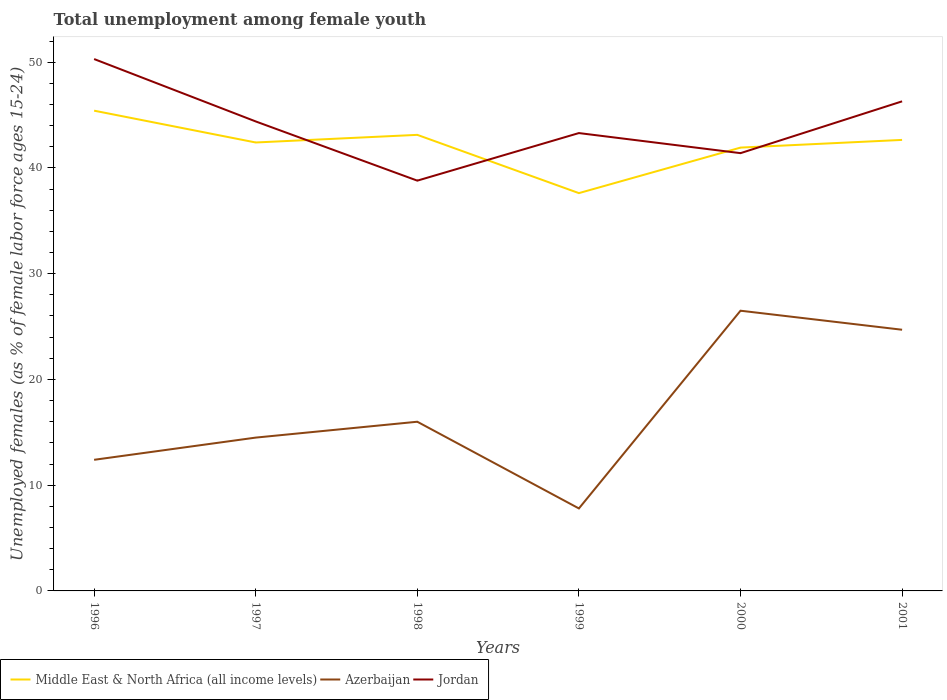Does the line corresponding to Azerbaijan intersect with the line corresponding to Middle East & North Africa (all income levels)?
Your answer should be very brief. No. Across all years, what is the maximum percentage of unemployed females in in Azerbaijan?
Your answer should be very brief. 7.8. What is the difference between the highest and the second highest percentage of unemployed females in in Azerbaijan?
Your answer should be very brief. 18.7. Does the graph contain any zero values?
Your answer should be compact. No. Does the graph contain grids?
Your answer should be very brief. No. Where does the legend appear in the graph?
Offer a very short reply. Bottom left. How are the legend labels stacked?
Give a very brief answer. Horizontal. What is the title of the graph?
Keep it short and to the point. Total unemployment among female youth. Does "Comoros" appear as one of the legend labels in the graph?
Make the answer very short. No. What is the label or title of the Y-axis?
Your answer should be very brief. Unemployed females (as % of female labor force ages 15-24). What is the Unemployed females (as % of female labor force ages 15-24) of Middle East & North Africa (all income levels) in 1996?
Keep it short and to the point. 45.42. What is the Unemployed females (as % of female labor force ages 15-24) in Azerbaijan in 1996?
Offer a very short reply. 12.4. What is the Unemployed females (as % of female labor force ages 15-24) in Jordan in 1996?
Offer a terse response. 50.3. What is the Unemployed females (as % of female labor force ages 15-24) in Middle East & North Africa (all income levels) in 1997?
Your answer should be compact. 42.41. What is the Unemployed females (as % of female labor force ages 15-24) in Azerbaijan in 1997?
Provide a succinct answer. 14.5. What is the Unemployed females (as % of female labor force ages 15-24) in Jordan in 1997?
Your response must be concise. 44.4. What is the Unemployed females (as % of female labor force ages 15-24) in Middle East & North Africa (all income levels) in 1998?
Your answer should be very brief. 43.13. What is the Unemployed females (as % of female labor force ages 15-24) in Jordan in 1998?
Your response must be concise. 38.8. What is the Unemployed females (as % of female labor force ages 15-24) in Middle East & North Africa (all income levels) in 1999?
Provide a short and direct response. 37.62. What is the Unemployed females (as % of female labor force ages 15-24) of Azerbaijan in 1999?
Provide a short and direct response. 7.8. What is the Unemployed females (as % of female labor force ages 15-24) of Jordan in 1999?
Make the answer very short. 43.3. What is the Unemployed females (as % of female labor force ages 15-24) of Middle East & North Africa (all income levels) in 2000?
Provide a short and direct response. 41.93. What is the Unemployed females (as % of female labor force ages 15-24) in Azerbaijan in 2000?
Your answer should be very brief. 26.5. What is the Unemployed females (as % of female labor force ages 15-24) of Jordan in 2000?
Your answer should be compact. 41.4. What is the Unemployed females (as % of female labor force ages 15-24) of Middle East & North Africa (all income levels) in 2001?
Offer a very short reply. 42.65. What is the Unemployed females (as % of female labor force ages 15-24) of Azerbaijan in 2001?
Your response must be concise. 24.7. What is the Unemployed females (as % of female labor force ages 15-24) of Jordan in 2001?
Make the answer very short. 46.3. Across all years, what is the maximum Unemployed females (as % of female labor force ages 15-24) of Middle East & North Africa (all income levels)?
Your answer should be compact. 45.42. Across all years, what is the maximum Unemployed females (as % of female labor force ages 15-24) of Jordan?
Provide a short and direct response. 50.3. Across all years, what is the minimum Unemployed females (as % of female labor force ages 15-24) of Middle East & North Africa (all income levels)?
Your answer should be very brief. 37.62. Across all years, what is the minimum Unemployed females (as % of female labor force ages 15-24) in Azerbaijan?
Make the answer very short. 7.8. Across all years, what is the minimum Unemployed females (as % of female labor force ages 15-24) in Jordan?
Your answer should be compact. 38.8. What is the total Unemployed females (as % of female labor force ages 15-24) of Middle East & North Africa (all income levels) in the graph?
Ensure brevity in your answer.  253.15. What is the total Unemployed females (as % of female labor force ages 15-24) in Azerbaijan in the graph?
Your response must be concise. 101.9. What is the total Unemployed females (as % of female labor force ages 15-24) of Jordan in the graph?
Your response must be concise. 264.5. What is the difference between the Unemployed females (as % of female labor force ages 15-24) in Middle East & North Africa (all income levels) in 1996 and that in 1997?
Your answer should be very brief. 3.01. What is the difference between the Unemployed females (as % of female labor force ages 15-24) of Jordan in 1996 and that in 1997?
Provide a succinct answer. 5.9. What is the difference between the Unemployed females (as % of female labor force ages 15-24) of Middle East & North Africa (all income levels) in 1996 and that in 1998?
Keep it short and to the point. 2.29. What is the difference between the Unemployed females (as % of female labor force ages 15-24) of Jordan in 1996 and that in 1998?
Offer a terse response. 11.5. What is the difference between the Unemployed females (as % of female labor force ages 15-24) of Middle East & North Africa (all income levels) in 1996 and that in 1999?
Ensure brevity in your answer.  7.8. What is the difference between the Unemployed females (as % of female labor force ages 15-24) in Azerbaijan in 1996 and that in 1999?
Keep it short and to the point. 4.6. What is the difference between the Unemployed females (as % of female labor force ages 15-24) of Middle East & North Africa (all income levels) in 1996 and that in 2000?
Provide a short and direct response. 3.49. What is the difference between the Unemployed females (as % of female labor force ages 15-24) in Azerbaijan in 1996 and that in 2000?
Your response must be concise. -14.1. What is the difference between the Unemployed females (as % of female labor force ages 15-24) of Jordan in 1996 and that in 2000?
Ensure brevity in your answer.  8.9. What is the difference between the Unemployed females (as % of female labor force ages 15-24) of Middle East & North Africa (all income levels) in 1996 and that in 2001?
Provide a succinct answer. 2.76. What is the difference between the Unemployed females (as % of female labor force ages 15-24) in Middle East & North Africa (all income levels) in 1997 and that in 1998?
Make the answer very short. -0.72. What is the difference between the Unemployed females (as % of female labor force ages 15-24) of Middle East & North Africa (all income levels) in 1997 and that in 1999?
Give a very brief answer. 4.79. What is the difference between the Unemployed females (as % of female labor force ages 15-24) of Azerbaijan in 1997 and that in 1999?
Offer a terse response. 6.7. What is the difference between the Unemployed females (as % of female labor force ages 15-24) of Jordan in 1997 and that in 1999?
Your response must be concise. 1.1. What is the difference between the Unemployed females (as % of female labor force ages 15-24) in Middle East & North Africa (all income levels) in 1997 and that in 2000?
Your answer should be very brief. 0.48. What is the difference between the Unemployed females (as % of female labor force ages 15-24) in Azerbaijan in 1997 and that in 2000?
Keep it short and to the point. -12. What is the difference between the Unemployed females (as % of female labor force ages 15-24) of Middle East & North Africa (all income levels) in 1997 and that in 2001?
Your answer should be compact. -0.24. What is the difference between the Unemployed females (as % of female labor force ages 15-24) in Jordan in 1997 and that in 2001?
Offer a very short reply. -1.9. What is the difference between the Unemployed females (as % of female labor force ages 15-24) of Middle East & North Africa (all income levels) in 1998 and that in 1999?
Give a very brief answer. 5.51. What is the difference between the Unemployed females (as % of female labor force ages 15-24) in Azerbaijan in 1998 and that in 1999?
Your answer should be very brief. 8.2. What is the difference between the Unemployed females (as % of female labor force ages 15-24) in Middle East & North Africa (all income levels) in 1998 and that in 2000?
Offer a very short reply. 1.2. What is the difference between the Unemployed females (as % of female labor force ages 15-24) of Jordan in 1998 and that in 2000?
Your answer should be very brief. -2.6. What is the difference between the Unemployed females (as % of female labor force ages 15-24) of Middle East & North Africa (all income levels) in 1998 and that in 2001?
Provide a short and direct response. 0.48. What is the difference between the Unemployed females (as % of female labor force ages 15-24) in Jordan in 1998 and that in 2001?
Your answer should be compact. -7.5. What is the difference between the Unemployed females (as % of female labor force ages 15-24) in Middle East & North Africa (all income levels) in 1999 and that in 2000?
Your answer should be very brief. -4.3. What is the difference between the Unemployed females (as % of female labor force ages 15-24) of Azerbaijan in 1999 and that in 2000?
Ensure brevity in your answer.  -18.7. What is the difference between the Unemployed females (as % of female labor force ages 15-24) of Middle East & North Africa (all income levels) in 1999 and that in 2001?
Your answer should be compact. -5.03. What is the difference between the Unemployed females (as % of female labor force ages 15-24) of Azerbaijan in 1999 and that in 2001?
Provide a succinct answer. -16.9. What is the difference between the Unemployed females (as % of female labor force ages 15-24) of Jordan in 1999 and that in 2001?
Your answer should be compact. -3. What is the difference between the Unemployed females (as % of female labor force ages 15-24) of Middle East & North Africa (all income levels) in 2000 and that in 2001?
Provide a succinct answer. -0.73. What is the difference between the Unemployed females (as % of female labor force ages 15-24) in Azerbaijan in 2000 and that in 2001?
Offer a terse response. 1.8. What is the difference between the Unemployed females (as % of female labor force ages 15-24) in Middle East & North Africa (all income levels) in 1996 and the Unemployed females (as % of female labor force ages 15-24) in Azerbaijan in 1997?
Offer a very short reply. 30.92. What is the difference between the Unemployed females (as % of female labor force ages 15-24) in Middle East & North Africa (all income levels) in 1996 and the Unemployed females (as % of female labor force ages 15-24) in Jordan in 1997?
Keep it short and to the point. 1.02. What is the difference between the Unemployed females (as % of female labor force ages 15-24) of Azerbaijan in 1996 and the Unemployed females (as % of female labor force ages 15-24) of Jordan in 1997?
Offer a terse response. -32. What is the difference between the Unemployed females (as % of female labor force ages 15-24) of Middle East & North Africa (all income levels) in 1996 and the Unemployed females (as % of female labor force ages 15-24) of Azerbaijan in 1998?
Offer a very short reply. 29.42. What is the difference between the Unemployed females (as % of female labor force ages 15-24) in Middle East & North Africa (all income levels) in 1996 and the Unemployed females (as % of female labor force ages 15-24) in Jordan in 1998?
Ensure brevity in your answer.  6.62. What is the difference between the Unemployed females (as % of female labor force ages 15-24) of Azerbaijan in 1996 and the Unemployed females (as % of female labor force ages 15-24) of Jordan in 1998?
Your response must be concise. -26.4. What is the difference between the Unemployed females (as % of female labor force ages 15-24) of Middle East & North Africa (all income levels) in 1996 and the Unemployed females (as % of female labor force ages 15-24) of Azerbaijan in 1999?
Offer a very short reply. 37.62. What is the difference between the Unemployed females (as % of female labor force ages 15-24) of Middle East & North Africa (all income levels) in 1996 and the Unemployed females (as % of female labor force ages 15-24) of Jordan in 1999?
Offer a terse response. 2.12. What is the difference between the Unemployed females (as % of female labor force ages 15-24) of Azerbaijan in 1996 and the Unemployed females (as % of female labor force ages 15-24) of Jordan in 1999?
Provide a succinct answer. -30.9. What is the difference between the Unemployed females (as % of female labor force ages 15-24) in Middle East & North Africa (all income levels) in 1996 and the Unemployed females (as % of female labor force ages 15-24) in Azerbaijan in 2000?
Your response must be concise. 18.92. What is the difference between the Unemployed females (as % of female labor force ages 15-24) of Middle East & North Africa (all income levels) in 1996 and the Unemployed females (as % of female labor force ages 15-24) of Jordan in 2000?
Offer a very short reply. 4.02. What is the difference between the Unemployed females (as % of female labor force ages 15-24) of Middle East & North Africa (all income levels) in 1996 and the Unemployed females (as % of female labor force ages 15-24) of Azerbaijan in 2001?
Provide a succinct answer. 20.72. What is the difference between the Unemployed females (as % of female labor force ages 15-24) of Middle East & North Africa (all income levels) in 1996 and the Unemployed females (as % of female labor force ages 15-24) of Jordan in 2001?
Offer a very short reply. -0.88. What is the difference between the Unemployed females (as % of female labor force ages 15-24) in Azerbaijan in 1996 and the Unemployed females (as % of female labor force ages 15-24) in Jordan in 2001?
Provide a short and direct response. -33.9. What is the difference between the Unemployed females (as % of female labor force ages 15-24) of Middle East & North Africa (all income levels) in 1997 and the Unemployed females (as % of female labor force ages 15-24) of Azerbaijan in 1998?
Provide a short and direct response. 26.41. What is the difference between the Unemployed females (as % of female labor force ages 15-24) of Middle East & North Africa (all income levels) in 1997 and the Unemployed females (as % of female labor force ages 15-24) of Jordan in 1998?
Make the answer very short. 3.61. What is the difference between the Unemployed females (as % of female labor force ages 15-24) in Azerbaijan in 1997 and the Unemployed females (as % of female labor force ages 15-24) in Jordan in 1998?
Provide a succinct answer. -24.3. What is the difference between the Unemployed females (as % of female labor force ages 15-24) of Middle East & North Africa (all income levels) in 1997 and the Unemployed females (as % of female labor force ages 15-24) of Azerbaijan in 1999?
Your answer should be compact. 34.61. What is the difference between the Unemployed females (as % of female labor force ages 15-24) of Middle East & North Africa (all income levels) in 1997 and the Unemployed females (as % of female labor force ages 15-24) of Jordan in 1999?
Offer a very short reply. -0.89. What is the difference between the Unemployed females (as % of female labor force ages 15-24) in Azerbaijan in 1997 and the Unemployed females (as % of female labor force ages 15-24) in Jordan in 1999?
Provide a short and direct response. -28.8. What is the difference between the Unemployed females (as % of female labor force ages 15-24) in Middle East & North Africa (all income levels) in 1997 and the Unemployed females (as % of female labor force ages 15-24) in Azerbaijan in 2000?
Your answer should be very brief. 15.91. What is the difference between the Unemployed females (as % of female labor force ages 15-24) in Middle East & North Africa (all income levels) in 1997 and the Unemployed females (as % of female labor force ages 15-24) in Jordan in 2000?
Your answer should be compact. 1.01. What is the difference between the Unemployed females (as % of female labor force ages 15-24) in Azerbaijan in 1997 and the Unemployed females (as % of female labor force ages 15-24) in Jordan in 2000?
Offer a very short reply. -26.9. What is the difference between the Unemployed females (as % of female labor force ages 15-24) of Middle East & North Africa (all income levels) in 1997 and the Unemployed females (as % of female labor force ages 15-24) of Azerbaijan in 2001?
Your answer should be very brief. 17.71. What is the difference between the Unemployed females (as % of female labor force ages 15-24) of Middle East & North Africa (all income levels) in 1997 and the Unemployed females (as % of female labor force ages 15-24) of Jordan in 2001?
Offer a terse response. -3.89. What is the difference between the Unemployed females (as % of female labor force ages 15-24) of Azerbaijan in 1997 and the Unemployed females (as % of female labor force ages 15-24) of Jordan in 2001?
Offer a terse response. -31.8. What is the difference between the Unemployed females (as % of female labor force ages 15-24) of Middle East & North Africa (all income levels) in 1998 and the Unemployed females (as % of female labor force ages 15-24) of Azerbaijan in 1999?
Provide a short and direct response. 35.33. What is the difference between the Unemployed females (as % of female labor force ages 15-24) in Middle East & North Africa (all income levels) in 1998 and the Unemployed females (as % of female labor force ages 15-24) in Jordan in 1999?
Your answer should be compact. -0.17. What is the difference between the Unemployed females (as % of female labor force ages 15-24) of Azerbaijan in 1998 and the Unemployed females (as % of female labor force ages 15-24) of Jordan in 1999?
Give a very brief answer. -27.3. What is the difference between the Unemployed females (as % of female labor force ages 15-24) in Middle East & North Africa (all income levels) in 1998 and the Unemployed females (as % of female labor force ages 15-24) in Azerbaijan in 2000?
Your answer should be compact. 16.63. What is the difference between the Unemployed females (as % of female labor force ages 15-24) in Middle East & North Africa (all income levels) in 1998 and the Unemployed females (as % of female labor force ages 15-24) in Jordan in 2000?
Your answer should be very brief. 1.73. What is the difference between the Unemployed females (as % of female labor force ages 15-24) of Azerbaijan in 1998 and the Unemployed females (as % of female labor force ages 15-24) of Jordan in 2000?
Keep it short and to the point. -25.4. What is the difference between the Unemployed females (as % of female labor force ages 15-24) of Middle East & North Africa (all income levels) in 1998 and the Unemployed females (as % of female labor force ages 15-24) of Azerbaijan in 2001?
Give a very brief answer. 18.43. What is the difference between the Unemployed females (as % of female labor force ages 15-24) of Middle East & North Africa (all income levels) in 1998 and the Unemployed females (as % of female labor force ages 15-24) of Jordan in 2001?
Offer a terse response. -3.17. What is the difference between the Unemployed females (as % of female labor force ages 15-24) of Azerbaijan in 1998 and the Unemployed females (as % of female labor force ages 15-24) of Jordan in 2001?
Your answer should be compact. -30.3. What is the difference between the Unemployed females (as % of female labor force ages 15-24) in Middle East & North Africa (all income levels) in 1999 and the Unemployed females (as % of female labor force ages 15-24) in Azerbaijan in 2000?
Your answer should be compact. 11.12. What is the difference between the Unemployed females (as % of female labor force ages 15-24) in Middle East & North Africa (all income levels) in 1999 and the Unemployed females (as % of female labor force ages 15-24) in Jordan in 2000?
Your response must be concise. -3.78. What is the difference between the Unemployed females (as % of female labor force ages 15-24) of Azerbaijan in 1999 and the Unemployed females (as % of female labor force ages 15-24) of Jordan in 2000?
Offer a terse response. -33.6. What is the difference between the Unemployed females (as % of female labor force ages 15-24) in Middle East & North Africa (all income levels) in 1999 and the Unemployed females (as % of female labor force ages 15-24) in Azerbaijan in 2001?
Make the answer very short. 12.92. What is the difference between the Unemployed females (as % of female labor force ages 15-24) in Middle East & North Africa (all income levels) in 1999 and the Unemployed females (as % of female labor force ages 15-24) in Jordan in 2001?
Ensure brevity in your answer.  -8.68. What is the difference between the Unemployed females (as % of female labor force ages 15-24) in Azerbaijan in 1999 and the Unemployed females (as % of female labor force ages 15-24) in Jordan in 2001?
Provide a short and direct response. -38.5. What is the difference between the Unemployed females (as % of female labor force ages 15-24) of Middle East & North Africa (all income levels) in 2000 and the Unemployed females (as % of female labor force ages 15-24) of Azerbaijan in 2001?
Ensure brevity in your answer.  17.23. What is the difference between the Unemployed females (as % of female labor force ages 15-24) of Middle East & North Africa (all income levels) in 2000 and the Unemployed females (as % of female labor force ages 15-24) of Jordan in 2001?
Ensure brevity in your answer.  -4.37. What is the difference between the Unemployed females (as % of female labor force ages 15-24) of Azerbaijan in 2000 and the Unemployed females (as % of female labor force ages 15-24) of Jordan in 2001?
Your answer should be very brief. -19.8. What is the average Unemployed females (as % of female labor force ages 15-24) in Middle East & North Africa (all income levels) per year?
Make the answer very short. 42.19. What is the average Unemployed females (as % of female labor force ages 15-24) in Azerbaijan per year?
Provide a short and direct response. 16.98. What is the average Unemployed females (as % of female labor force ages 15-24) of Jordan per year?
Your answer should be very brief. 44.08. In the year 1996, what is the difference between the Unemployed females (as % of female labor force ages 15-24) of Middle East & North Africa (all income levels) and Unemployed females (as % of female labor force ages 15-24) of Azerbaijan?
Provide a succinct answer. 33.02. In the year 1996, what is the difference between the Unemployed females (as % of female labor force ages 15-24) in Middle East & North Africa (all income levels) and Unemployed females (as % of female labor force ages 15-24) in Jordan?
Ensure brevity in your answer.  -4.88. In the year 1996, what is the difference between the Unemployed females (as % of female labor force ages 15-24) in Azerbaijan and Unemployed females (as % of female labor force ages 15-24) in Jordan?
Offer a very short reply. -37.9. In the year 1997, what is the difference between the Unemployed females (as % of female labor force ages 15-24) in Middle East & North Africa (all income levels) and Unemployed females (as % of female labor force ages 15-24) in Azerbaijan?
Provide a succinct answer. 27.91. In the year 1997, what is the difference between the Unemployed females (as % of female labor force ages 15-24) of Middle East & North Africa (all income levels) and Unemployed females (as % of female labor force ages 15-24) of Jordan?
Give a very brief answer. -1.99. In the year 1997, what is the difference between the Unemployed females (as % of female labor force ages 15-24) in Azerbaijan and Unemployed females (as % of female labor force ages 15-24) in Jordan?
Your answer should be compact. -29.9. In the year 1998, what is the difference between the Unemployed females (as % of female labor force ages 15-24) of Middle East & North Africa (all income levels) and Unemployed females (as % of female labor force ages 15-24) of Azerbaijan?
Your answer should be very brief. 27.13. In the year 1998, what is the difference between the Unemployed females (as % of female labor force ages 15-24) in Middle East & North Africa (all income levels) and Unemployed females (as % of female labor force ages 15-24) in Jordan?
Give a very brief answer. 4.33. In the year 1998, what is the difference between the Unemployed females (as % of female labor force ages 15-24) in Azerbaijan and Unemployed females (as % of female labor force ages 15-24) in Jordan?
Your response must be concise. -22.8. In the year 1999, what is the difference between the Unemployed females (as % of female labor force ages 15-24) of Middle East & North Africa (all income levels) and Unemployed females (as % of female labor force ages 15-24) of Azerbaijan?
Make the answer very short. 29.82. In the year 1999, what is the difference between the Unemployed females (as % of female labor force ages 15-24) in Middle East & North Africa (all income levels) and Unemployed females (as % of female labor force ages 15-24) in Jordan?
Offer a terse response. -5.68. In the year 1999, what is the difference between the Unemployed females (as % of female labor force ages 15-24) in Azerbaijan and Unemployed females (as % of female labor force ages 15-24) in Jordan?
Your response must be concise. -35.5. In the year 2000, what is the difference between the Unemployed females (as % of female labor force ages 15-24) of Middle East & North Africa (all income levels) and Unemployed females (as % of female labor force ages 15-24) of Azerbaijan?
Your answer should be very brief. 15.43. In the year 2000, what is the difference between the Unemployed females (as % of female labor force ages 15-24) in Middle East & North Africa (all income levels) and Unemployed females (as % of female labor force ages 15-24) in Jordan?
Your answer should be compact. 0.53. In the year 2000, what is the difference between the Unemployed females (as % of female labor force ages 15-24) of Azerbaijan and Unemployed females (as % of female labor force ages 15-24) of Jordan?
Give a very brief answer. -14.9. In the year 2001, what is the difference between the Unemployed females (as % of female labor force ages 15-24) in Middle East & North Africa (all income levels) and Unemployed females (as % of female labor force ages 15-24) in Azerbaijan?
Your response must be concise. 17.95. In the year 2001, what is the difference between the Unemployed females (as % of female labor force ages 15-24) in Middle East & North Africa (all income levels) and Unemployed females (as % of female labor force ages 15-24) in Jordan?
Your answer should be very brief. -3.65. In the year 2001, what is the difference between the Unemployed females (as % of female labor force ages 15-24) of Azerbaijan and Unemployed females (as % of female labor force ages 15-24) of Jordan?
Ensure brevity in your answer.  -21.6. What is the ratio of the Unemployed females (as % of female labor force ages 15-24) in Middle East & North Africa (all income levels) in 1996 to that in 1997?
Give a very brief answer. 1.07. What is the ratio of the Unemployed females (as % of female labor force ages 15-24) in Azerbaijan in 1996 to that in 1997?
Keep it short and to the point. 0.86. What is the ratio of the Unemployed females (as % of female labor force ages 15-24) in Jordan in 1996 to that in 1997?
Ensure brevity in your answer.  1.13. What is the ratio of the Unemployed females (as % of female labor force ages 15-24) in Middle East & North Africa (all income levels) in 1996 to that in 1998?
Make the answer very short. 1.05. What is the ratio of the Unemployed females (as % of female labor force ages 15-24) in Azerbaijan in 1996 to that in 1998?
Keep it short and to the point. 0.78. What is the ratio of the Unemployed females (as % of female labor force ages 15-24) of Jordan in 1996 to that in 1998?
Your answer should be very brief. 1.3. What is the ratio of the Unemployed females (as % of female labor force ages 15-24) of Middle East & North Africa (all income levels) in 1996 to that in 1999?
Your answer should be very brief. 1.21. What is the ratio of the Unemployed females (as % of female labor force ages 15-24) in Azerbaijan in 1996 to that in 1999?
Offer a terse response. 1.59. What is the ratio of the Unemployed females (as % of female labor force ages 15-24) in Jordan in 1996 to that in 1999?
Your answer should be very brief. 1.16. What is the ratio of the Unemployed females (as % of female labor force ages 15-24) in Azerbaijan in 1996 to that in 2000?
Offer a terse response. 0.47. What is the ratio of the Unemployed females (as % of female labor force ages 15-24) in Jordan in 1996 to that in 2000?
Provide a short and direct response. 1.22. What is the ratio of the Unemployed females (as % of female labor force ages 15-24) of Middle East & North Africa (all income levels) in 1996 to that in 2001?
Your answer should be compact. 1.06. What is the ratio of the Unemployed females (as % of female labor force ages 15-24) of Azerbaijan in 1996 to that in 2001?
Give a very brief answer. 0.5. What is the ratio of the Unemployed females (as % of female labor force ages 15-24) in Jordan in 1996 to that in 2001?
Provide a succinct answer. 1.09. What is the ratio of the Unemployed females (as % of female labor force ages 15-24) in Middle East & North Africa (all income levels) in 1997 to that in 1998?
Your answer should be very brief. 0.98. What is the ratio of the Unemployed females (as % of female labor force ages 15-24) of Azerbaijan in 1997 to that in 1998?
Make the answer very short. 0.91. What is the ratio of the Unemployed females (as % of female labor force ages 15-24) of Jordan in 1997 to that in 1998?
Your response must be concise. 1.14. What is the ratio of the Unemployed females (as % of female labor force ages 15-24) of Middle East & North Africa (all income levels) in 1997 to that in 1999?
Make the answer very short. 1.13. What is the ratio of the Unemployed females (as % of female labor force ages 15-24) of Azerbaijan in 1997 to that in 1999?
Your answer should be compact. 1.86. What is the ratio of the Unemployed females (as % of female labor force ages 15-24) in Jordan in 1997 to that in 1999?
Offer a very short reply. 1.03. What is the ratio of the Unemployed females (as % of female labor force ages 15-24) in Middle East & North Africa (all income levels) in 1997 to that in 2000?
Ensure brevity in your answer.  1.01. What is the ratio of the Unemployed females (as % of female labor force ages 15-24) of Azerbaijan in 1997 to that in 2000?
Keep it short and to the point. 0.55. What is the ratio of the Unemployed females (as % of female labor force ages 15-24) of Jordan in 1997 to that in 2000?
Ensure brevity in your answer.  1.07. What is the ratio of the Unemployed females (as % of female labor force ages 15-24) of Middle East & North Africa (all income levels) in 1997 to that in 2001?
Ensure brevity in your answer.  0.99. What is the ratio of the Unemployed females (as % of female labor force ages 15-24) of Azerbaijan in 1997 to that in 2001?
Give a very brief answer. 0.59. What is the ratio of the Unemployed females (as % of female labor force ages 15-24) of Jordan in 1997 to that in 2001?
Give a very brief answer. 0.96. What is the ratio of the Unemployed females (as % of female labor force ages 15-24) in Middle East & North Africa (all income levels) in 1998 to that in 1999?
Your response must be concise. 1.15. What is the ratio of the Unemployed females (as % of female labor force ages 15-24) in Azerbaijan in 1998 to that in 1999?
Provide a succinct answer. 2.05. What is the ratio of the Unemployed females (as % of female labor force ages 15-24) in Jordan in 1998 to that in 1999?
Provide a succinct answer. 0.9. What is the ratio of the Unemployed females (as % of female labor force ages 15-24) of Middle East & North Africa (all income levels) in 1998 to that in 2000?
Provide a short and direct response. 1.03. What is the ratio of the Unemployed females (as % of female labor force ages 15-24) of Azerbaijan in 1998 to that in 2000?
Your answer should be compact. 0.6. What is the ratio of the Unemployed females (as % of female labor force ages 15-24) in Jordan in 1998 to that in 2000?
Your answer should be very brief. 0.94. What is the ratio of the Unemployed females (as % of female labor force ages 15-24) of Middle East & North Africa (all income levels) in 1998 to that in 2001?
Your answer should be compact. 1.01. What is the ratio of the Unemployed females (as % of female labor force ages 15-24) in Azerbaijan in 1998 to that in 2001?
Provide a succinct answer. 0.65. What is the ratio of the Unemployed females (as % of female labor force ages 15-24) of Jordan in 1998 to that in 2001?
Give a very brief answer. 0.84. What is the ratio of the Unemployed females (as % of female labor force ages 15-24) of Middle East & North Africa (all income levels) in 1999 to that in 2000?
Keep it short and to the point. 0.9. What is the ratio of the Unemployed females (as % of female labor force ages 15-24) of Azerbaijan in 1999 to that in 2000?
Give a very brief answer. 0.29. What is the ratio of the Unemployed females (as % of female labor force ages 15-24) of Jordan in 1999 to that in 2000?
Give a very brief answer. 1.05. What is the ratio of the Unemployed females (as % of female labor force ages 15-24) in Middle East & North Africa (all income levels) in 1999 to that in 2001?
Offer a very short reply. 0.88. What is the ratio of the Unemployed females (as % of female labor force ages 15-24) in Azerbaijan in 1999 to that in 2001?
Provide a short and direct response. 0.32. What is the ratio of the Unemployed females (as % of female labor force ages 15-24) in Jordan in 1999 to that in 2001?
Offer a very short reply. 0.94. What is the ratio of the Unemployed females (as % of female labor force ages 15-24) in Middle East & North Africa (all income levels) in 2000 to that in 2001?
Make the answer very short. 0.98. What is the ratio of the Unemployed females (as % of female labor force ages 15-24) in Azerbaijan in 2000 to that in 2001?
Your answer should be compact. 1.07. What is the ratio of the Unemployed females (as % of female labor force ages 15-24) in Jordan in 2000 to that in 2001?
Your response must be concise. 0.89. What is the difference between the highest and the second highest Unemployed females (as % of female labor force ages 15-24) of Middle East & North Africa (all income levels)?
Provide a succinct answer. 2.29. What is the difference between the highest and the lowest Unemployed females (as % of female labor force ages 15-24) of Middle East & North Africa (all income levels)?
Your answer should be very brief. 7.8. 